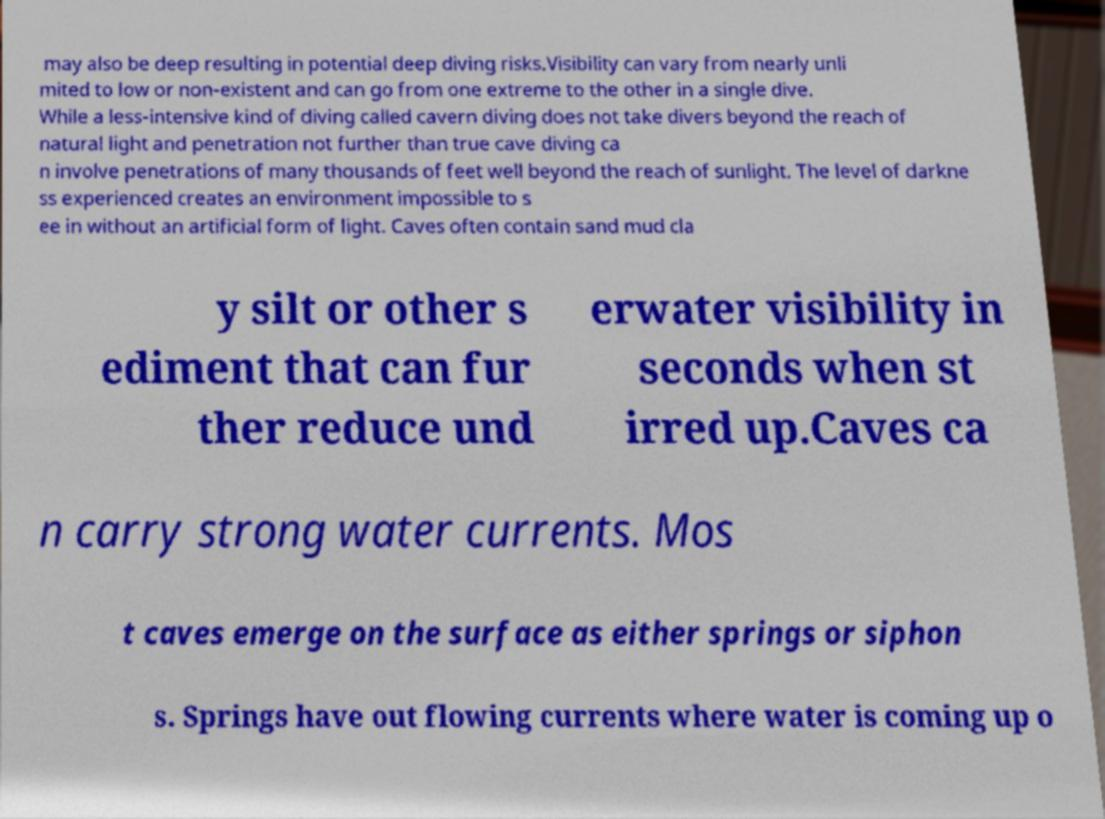What messages or text are displayed in this image? I need them in a readable, typed format. may also be deep resulting in potential deep diving risks.Visibility can vary from nearly unli mited to low or non-existent and can go from one extreme to the other in a single dive. While a less-intensive kind of diving called cavern diving does not take divers beyond the reach of natural light and penetration not further than true cave diving ca n involve penetrations of many thousands of feet well beyond the reach of sunlight. The level of darkne ss experienced creates an environment impossible to s ee in without an artificial form of light. Caves often contain sand mud cla y silt or other s ediment that can fur ther reduce und erwater visibility in seconds when st irred up.Caves ca n carry strong water currents. Mos t caves emerge on the surface as either springs or siphon s. Springs have out flowing currents where water is coming up o 